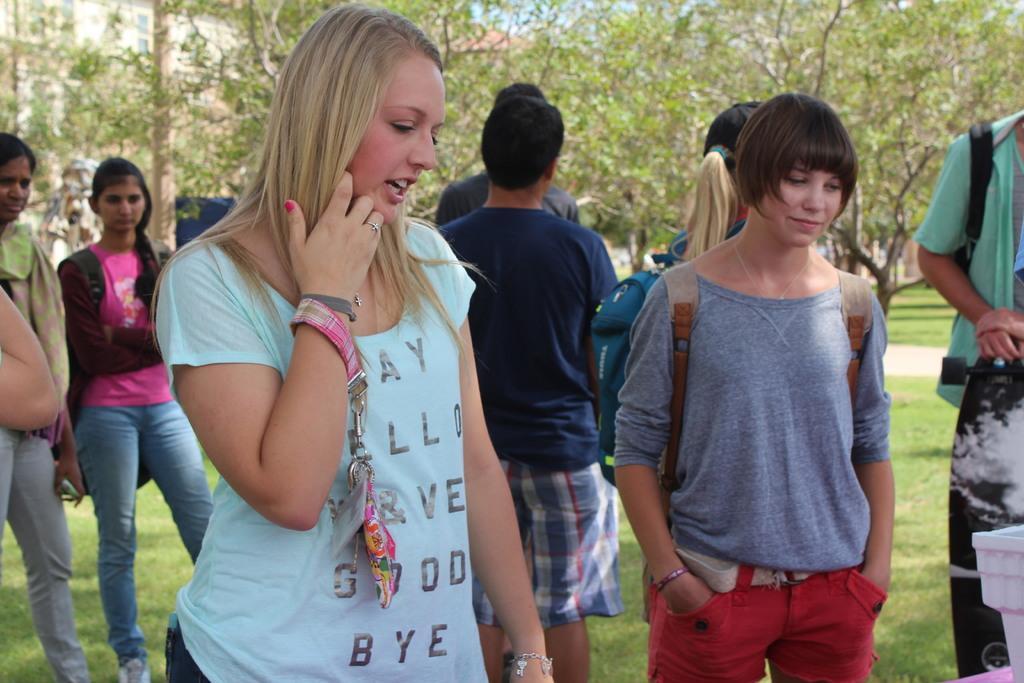Describe this image in one or two sentences. In front of the image there is a lady standing. Around her hand there is a tag with an identity card. Behind her there are few people standing. On the ground there is grass. In the background there are trees. Behind the trees on the left side there is a building. 